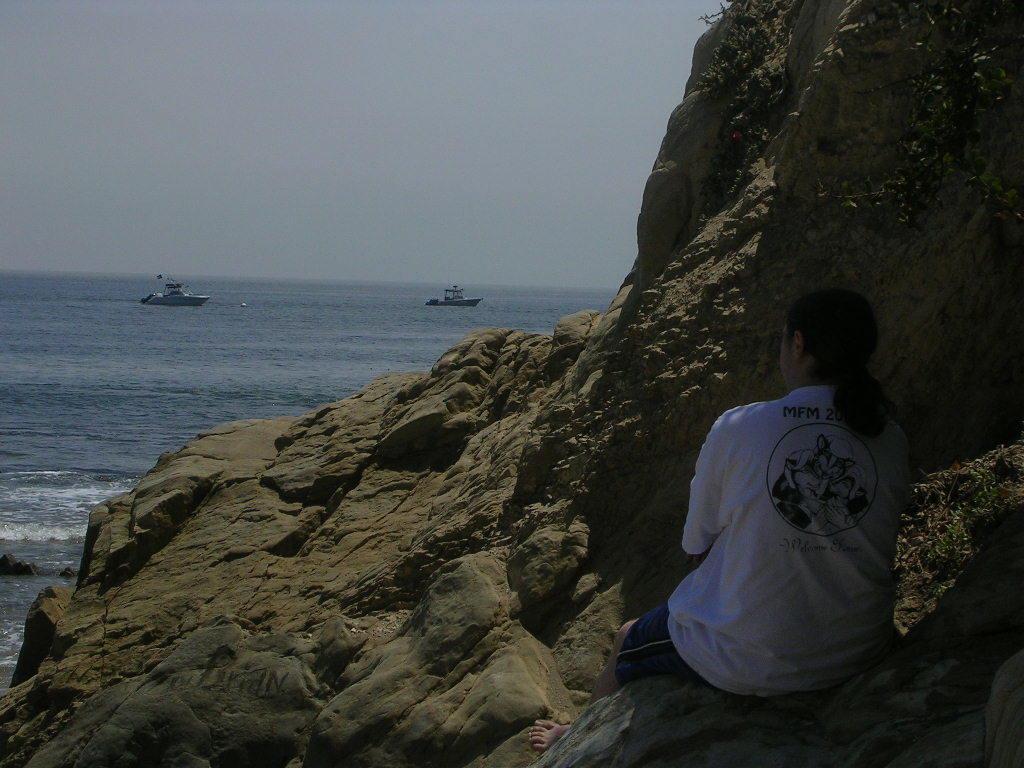Describe this image in one or two sentences. In this image a person sitting on a mountain, in the background there is a sea on that sea there are two ships. 